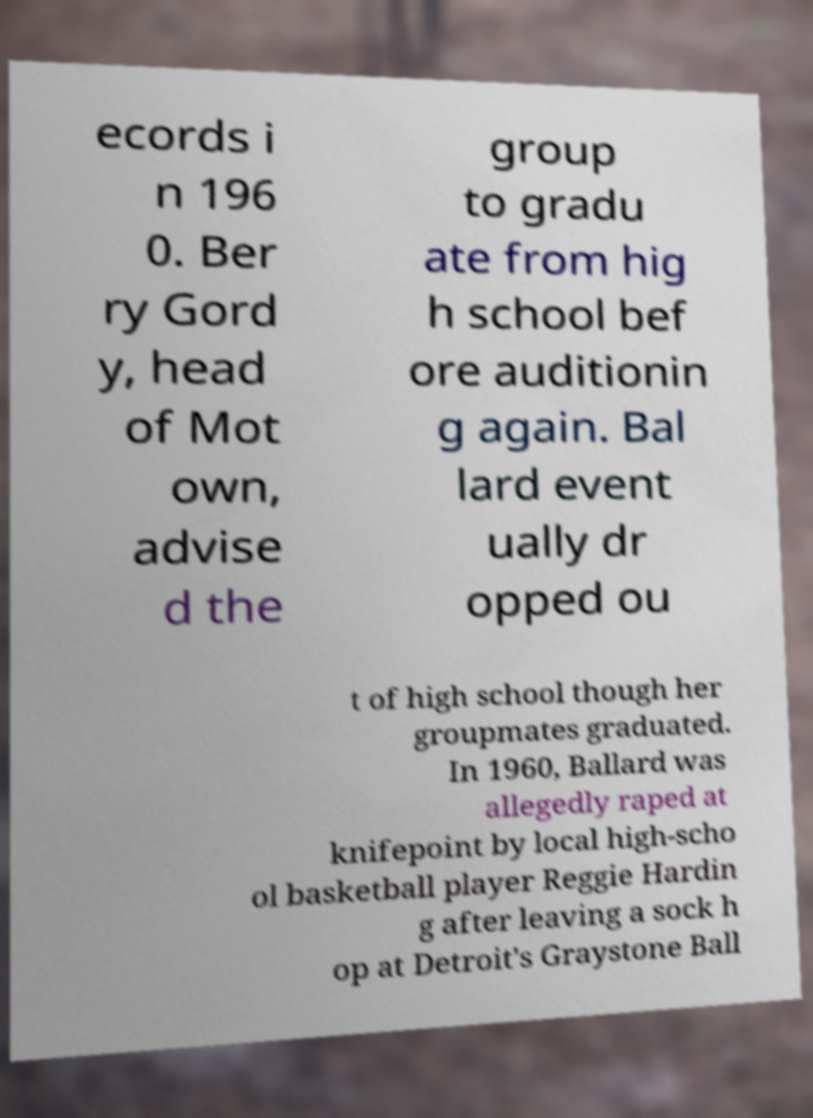Please read and relay the text visible in this image. What does it say? ecords i n 196 0. Ber ry Gord y, head of Mot own, advise d the group to gradu ate from hig h school bef ore auditionin g again. Bal lard event ually dr opped ou t of high school though her groupmates graduated. In 1960, Ballard was allegedly raped at knifepoint by local high-scho ol basketball player Reggie Hardin g after leaving a sock h op at Detroit's Graystone Ball 